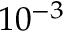Convert formula to latex. <formula><loc_0><loc_0><loc_500><loc_500>1 0 ^ { - 3 }</formula> 